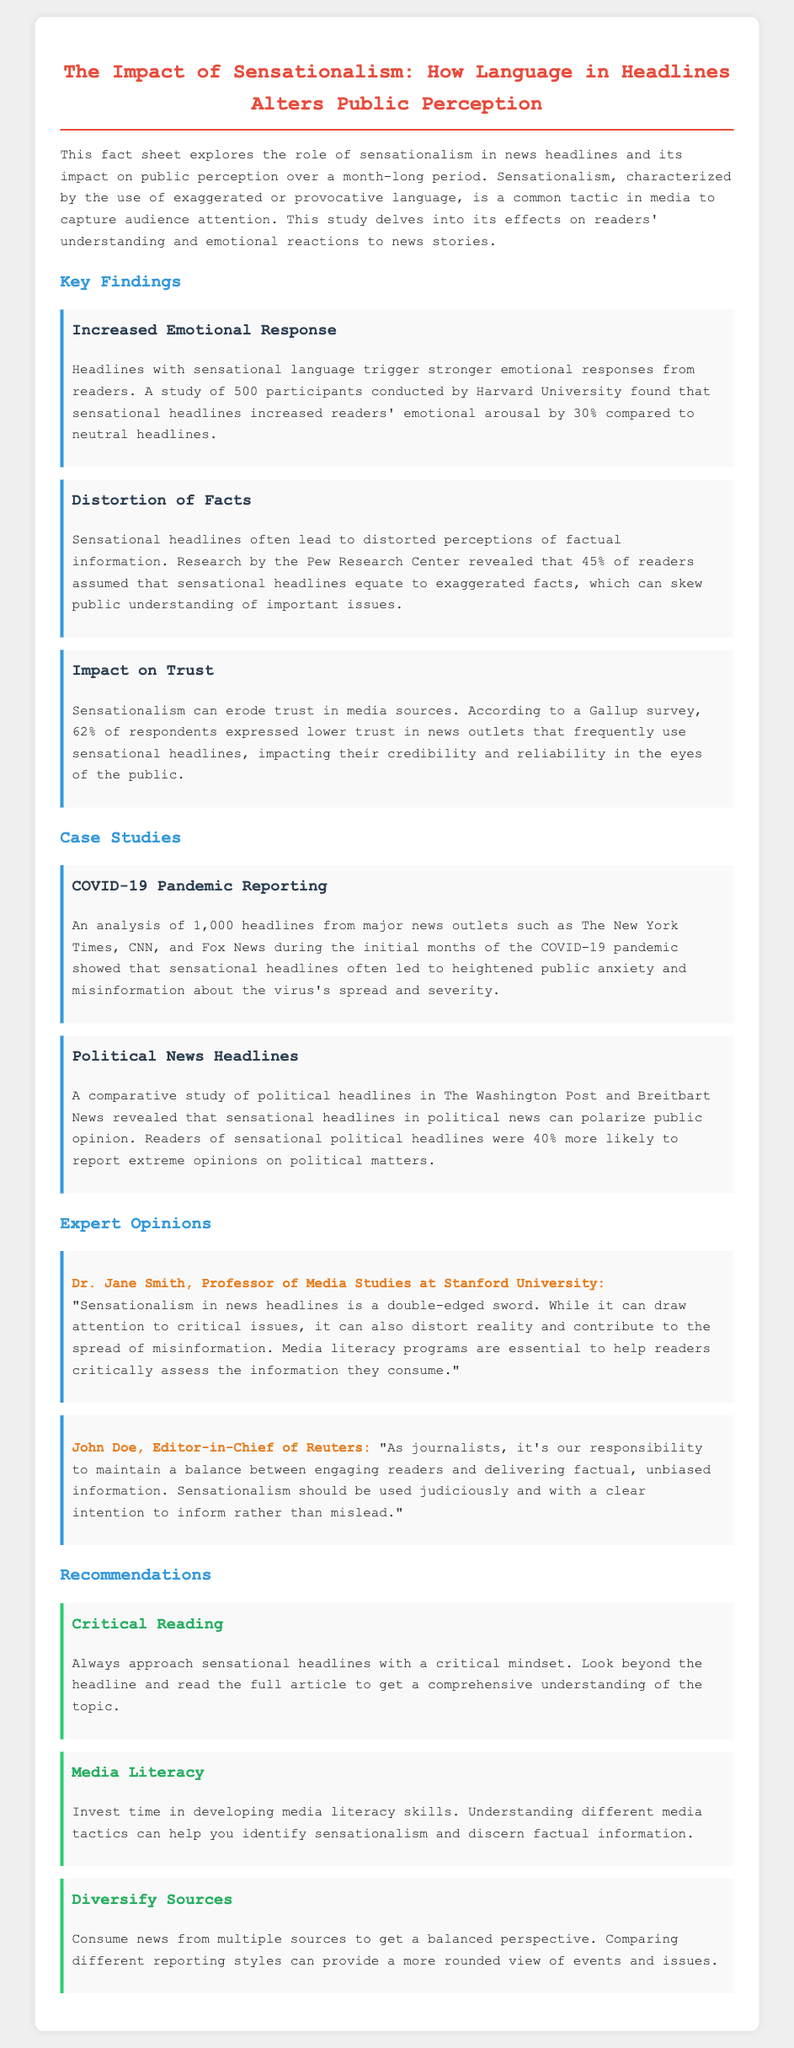what is the percentage increase in emotional arousal from sensational headlines? Sensational headlines increased readers' emotional arousal by 30% compared to neutral headlines, as found in the study conducted by Harvard University.
Answer: 30% what percentage of readers assume that sensational headlines equate to exaggerated facts? According to research by the Pew Research Center, 45% of readers assumed that sensational headlines equate to exaggerated facts.
Answer: 45% who conducted a study on the emotional response to sensational headlines? The study was conducted by Harvard University, focusing on readers' emotional responses to sensational headlines.
Answer: Harvard University what has a 62% impact on public trust? According to a Gallup survey, 62% of respondents expressed lower trust in news outlets that frequently use sensational headlines, impacting their credibility.
Answer: 62% which major news outlets were analyzed during the COVID-19 pandemic reporting case study? The analysis included major news outlets such as The New York Times, CNN, and Fox News during the initial months of the COVID-19 pandemic.
Answer: The New York Times, CNN, and Fox News who is the Professor of Media Studies at Stanford University quoted in the document? Dr. Jane Smith is the Professor of Media Studies at Stanford University quoted in the document regarding sensationalism in news.
Answer: Dr. Jane Smith what should readers do with sensational headlines according to the recommendations? The recommendation suggests that readers should always approach sensational headlines with a critical mindset.
Answer: Critical mindset how much more likely are readers of sensational political headlines to report extreme opinions? Readers of sensational political headlines were 40% more likely to report extreme opinions on political matters according to the comparative study.
Answer: 40% what is a recommended strategy for consuming news? One of the recommendations is to consume news from multiple sources to get a balanced perspective.
Answer: Diversify Sources 